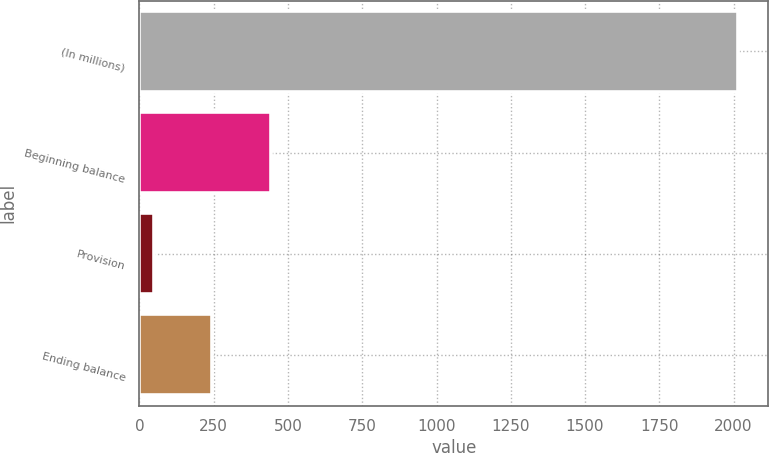Convert chart to OTSL. <chart><loc_0><loc_0><loc_500><loc_500><bar_chart><fcel>(In millions)<fcel>Beginning balance<fcel>Provision<fcel>Ending balance<nl><fcel>2015<fcel>441.4<fcel>48<fcel>244.7<nl></chart> 